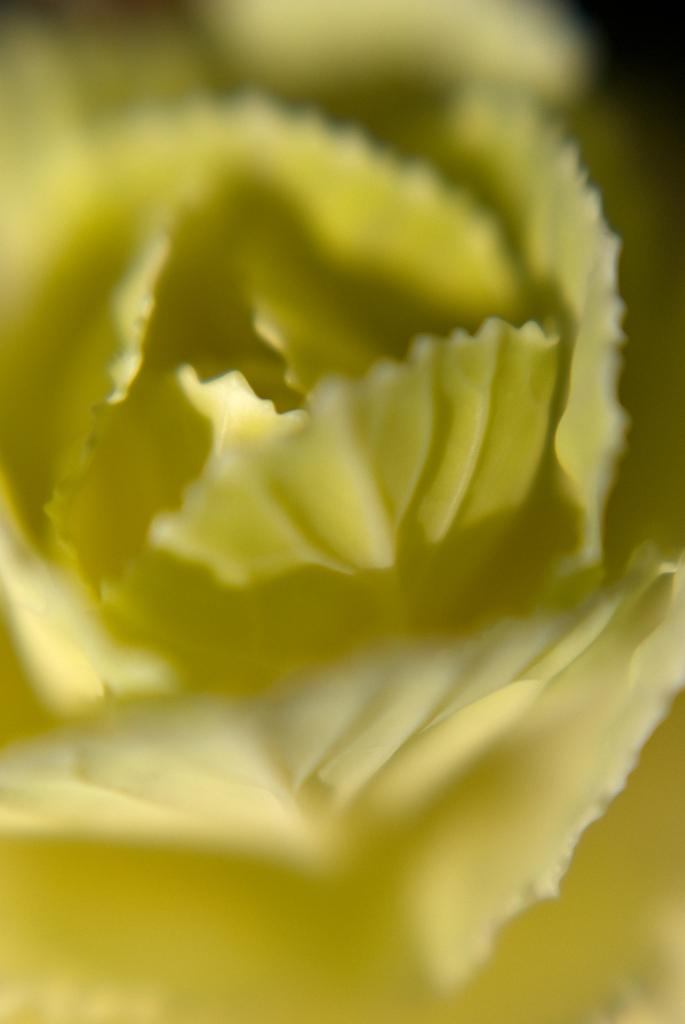What type of vegetation is visible in the front of the image? There are leaves in the front of the image. How many brothers are participating in the battle depicted in the image? There is no depiction of brothers or a battle in the image; it only features leaves in the front. 